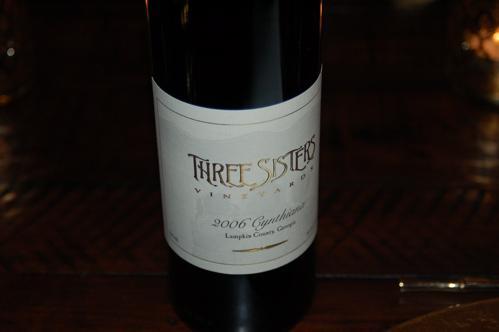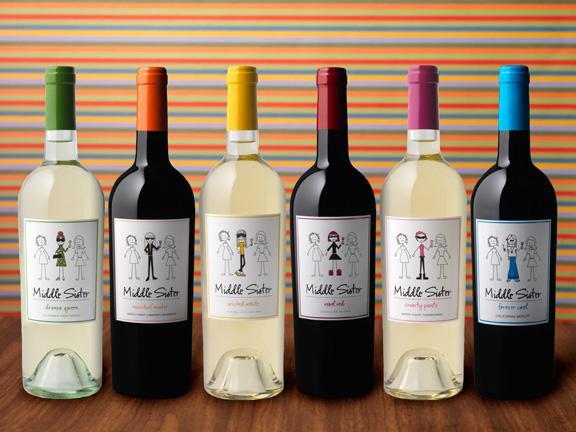The first image is the image on the left, the second image is the image on the right. Examine the images to the left and right. Is the description "Left image shows at least four wine bottles of various colors, arranged in a horizontal row." accurate? Answer yes or no. No. 